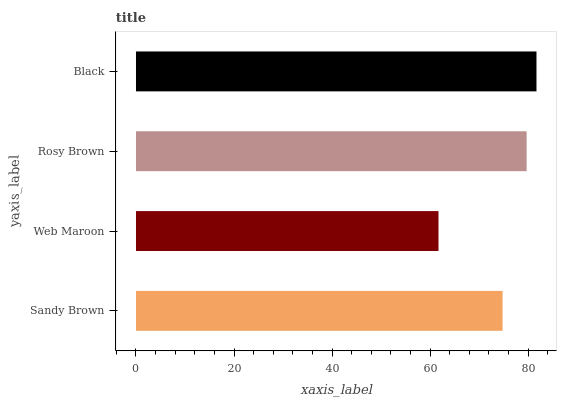Is Web Maroon the minimum?
Answer yes or no. Yes. Is Black the maximum?
Answer yes or no. Yes. Is Rosy Brown the minimum?
Answer yes or no. No. Is Rosy Brown the maximum?
Answer yes or no. No. Is Rosy Brown greater than Web Maroon?
Answer yes or no. Yes. Is Web Maroon less than Rosy Brown?
Answer yes or no. Yes. Is Web Maroon greater than Rosy Brown?
Answer yes or no. No. Is Rosy Brown less than Web Maroon?
Answer yes or no. No. Is Rosy Brown the high median?
Answer yes or no. Yes. Is Sandy Brown the low median?
Answer yes or no. Yes. Is Web Maroon the high median?
Answer yes or no. No. Is Rosy Brown the low median?
Answer yes or no. No. 